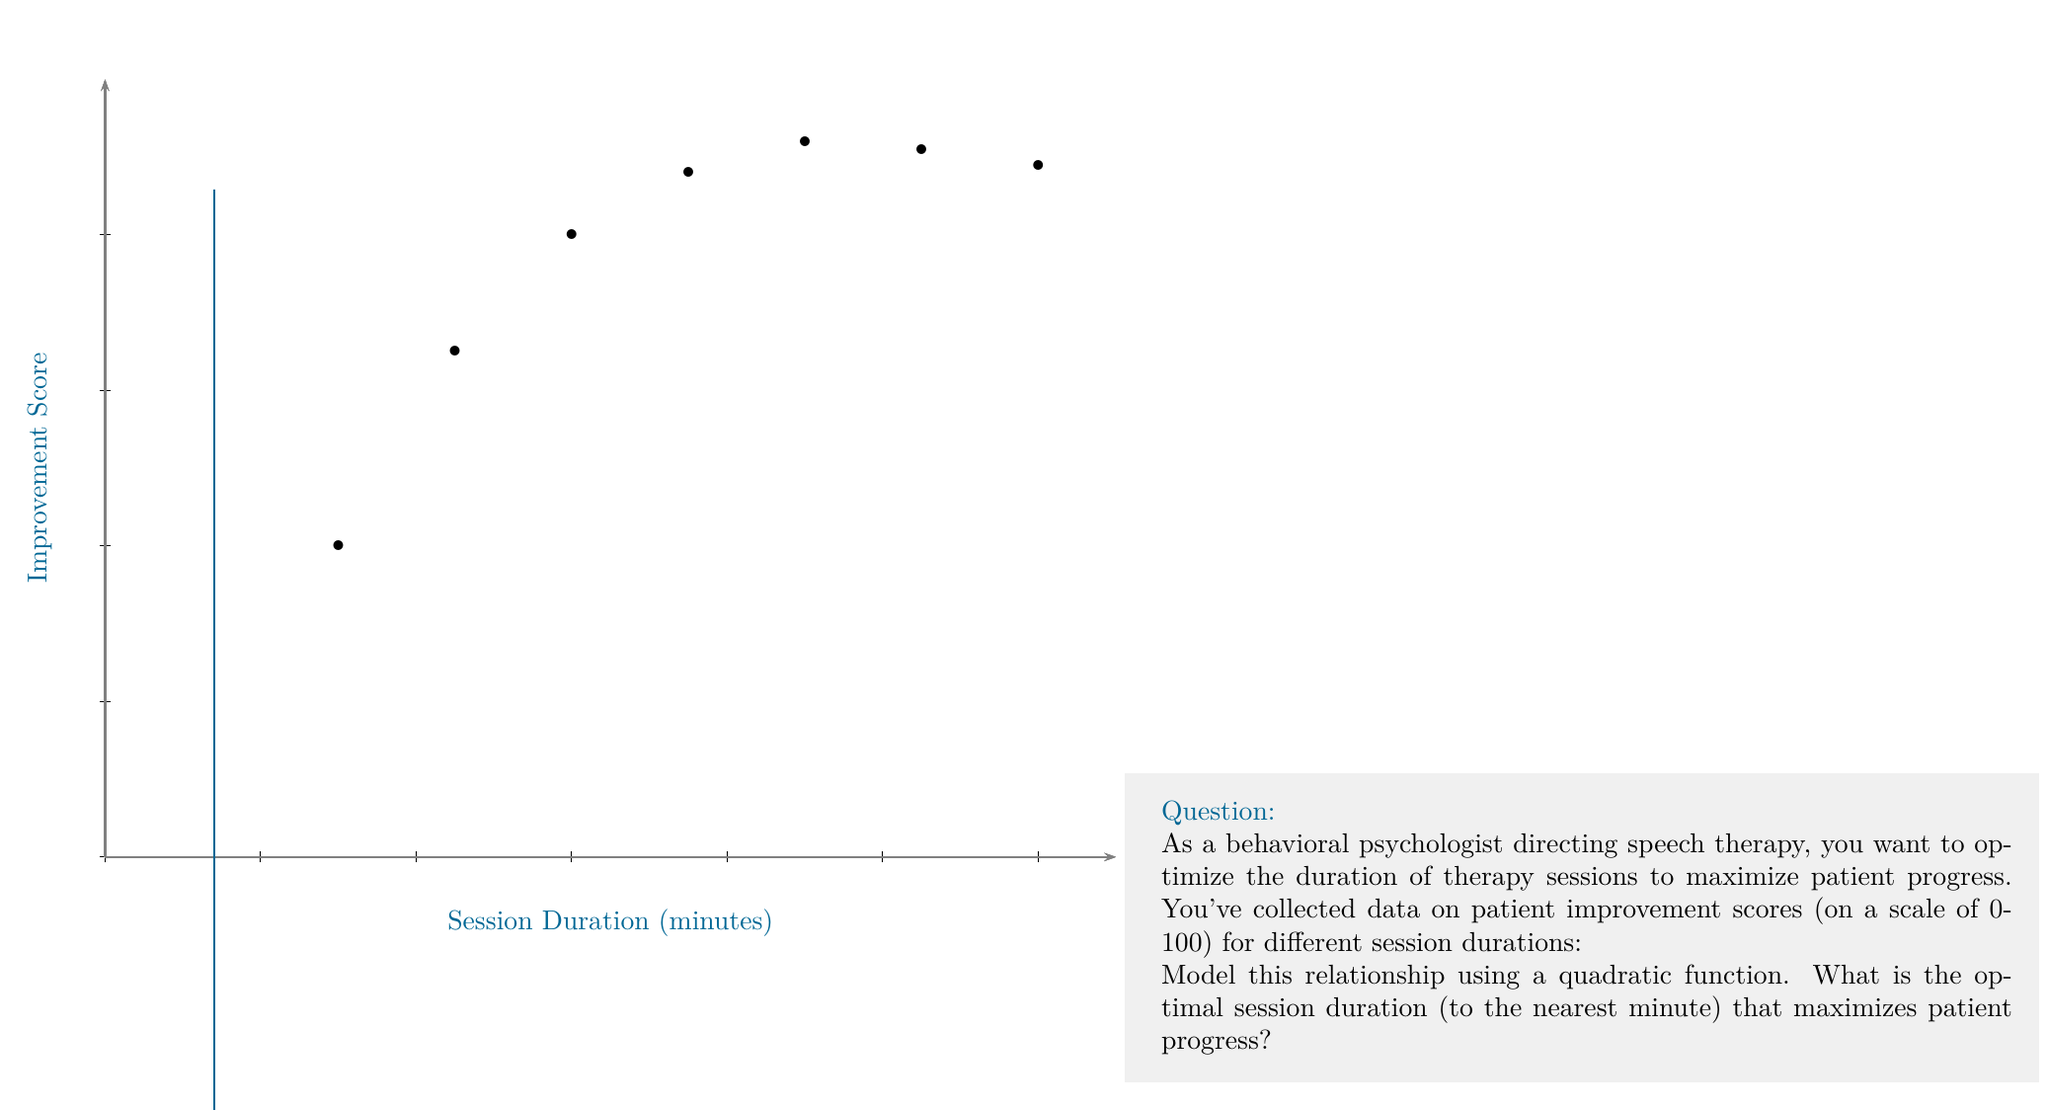Provide a solution to this math problem. To solve this optimization problem, we'll follow these steps:

1) First, we need to find the quadratic function that best fits the data. The general form of a quadratic function is:

   $$f(x) = ax^2 + bx + c$$

   where $x$ is the session duration and $f(x)$ is the improvement score.

2) Using a quadratic regression (which can be done with a graphing calculator or statistical software), we get the following function:

   $$f(x) = -0.0062x^2 + 1.1929x - 6.3571$$

3) To find the maximum of this function, we need to find the vertex of the parabola. The x-coordinate of the vertex gives us the optimal session duration.

4) For a quadratic function $f(x) = ax^2 + bx + c$, the x-coordinate of the vertex is given by:

   $$x = -\frac{b}{2a}$$

5) Substituting our values:

   $$x = -\frac{1.1929}{2(-0.0062)} = 96.2016$$

6) Rounding to the nearest minute, we get 96 minutes.

7) We can verify this is a maximum (not a minimum) because $a$ is negative, making the parabola open downward.
Answer: 96 minutes 